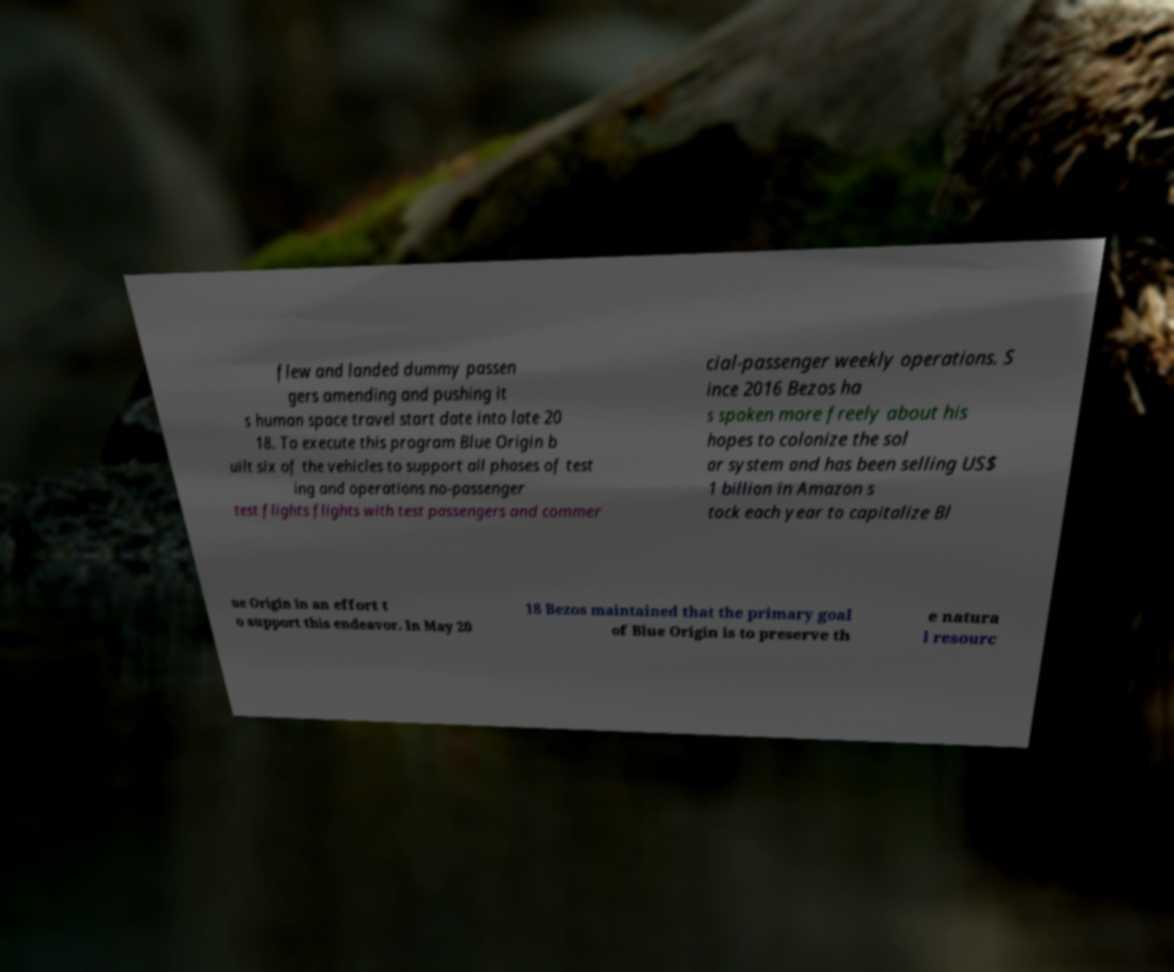I need the written content from this picture converted into text. Can you do that? flew and landed dummy passen gers amending and pushing it s human space travel start date into late 20 18. To execute this program Blue Origin b uilt six of the vehicles to support all phases of test ing and operations no-passenger test flights flights with test passengers and commer cial-passenger weekly operations. S ince 2016 Bezos ha s spoken more freely about his hopes to colonize the sol ar system and has been selling US$ 1 billion in Amazon s tock each year to capitalize Bl ue Origin in an effort t o support this endeavor. In May 20 18 Bezos maintained that the primary goal of Blue Origin is to preserve th e natura l resourc 